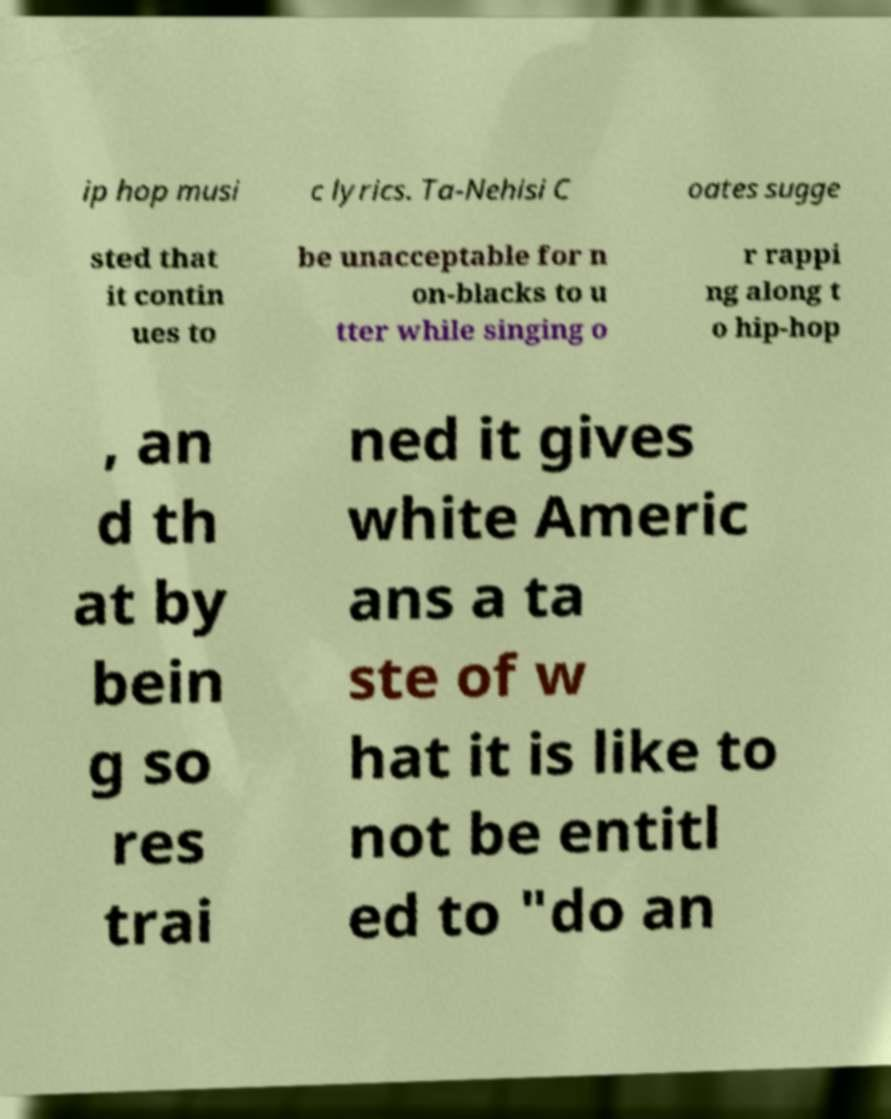What messages or text are displayed in this image? I need them in a readable, typed format. ip hop musi c lyrics. Ta-Nehisi C oates sugge sted that it contin ues to be unacceptable for n on-blacks to u tter while singing o r rappi ng along t o hip-hop , an d th at by bein g so res trai ned it gives white Americ ans a ta ste of w hat it is like to not be entitl ed to "do an 